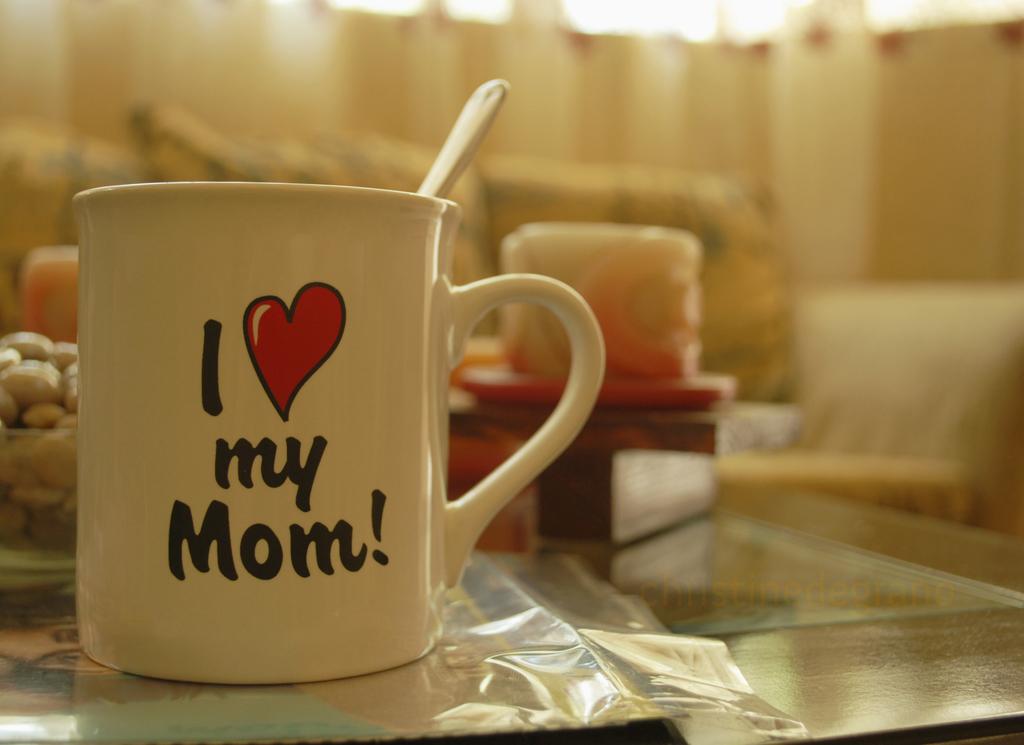Who does the coffee cup say is loved?
Offer a very short reply. Mom. Whose mom do i love?
Ensure brevity in your answer.  My. 